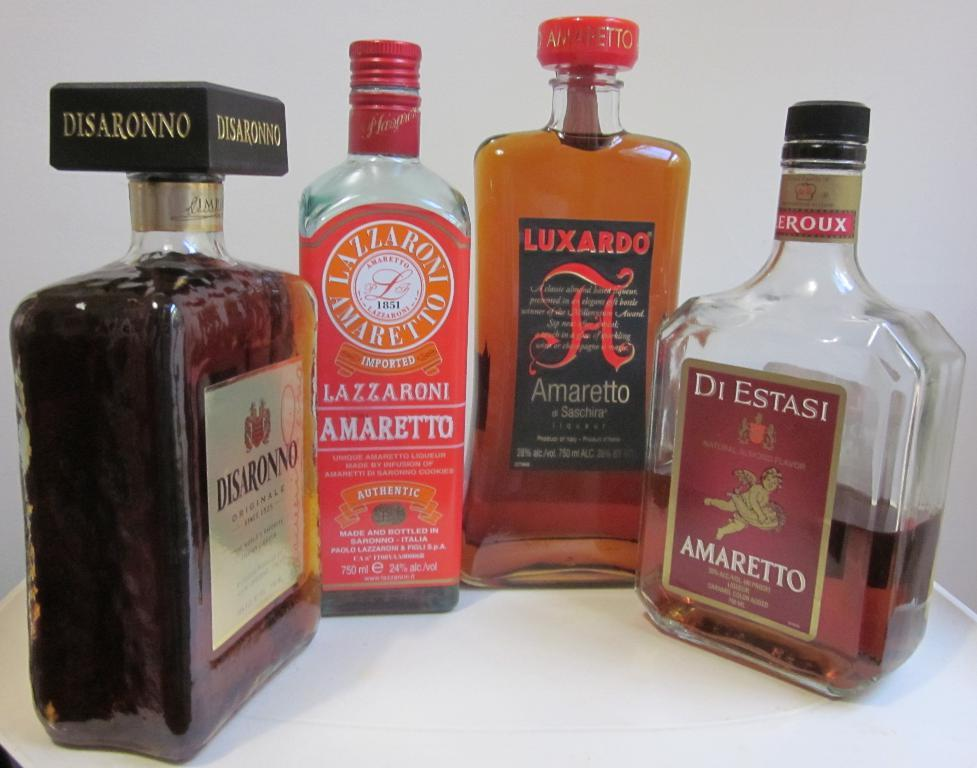<image>
Summarize the visual content of the image. A bottle of amarett from Di Estasi sits among other alcohol bottles. 